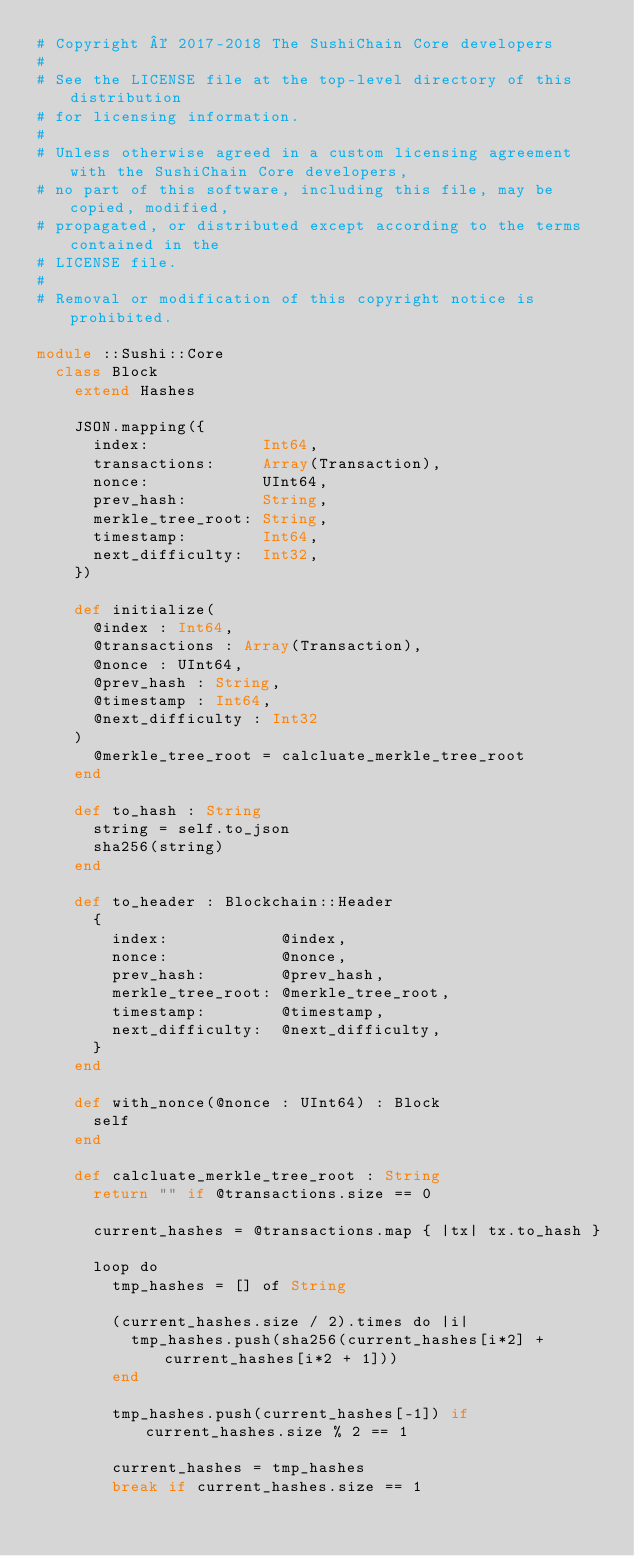<code> <loc_0><loc_0><loc_500><loc_500><_Crystal_># Copyright © 2017-2018 The SushiChain Core developers
#
# See the LICENSE file at the top-level directory of this distribution
# for licensing information.
#
# Unless otherwise agreed in a custom licensing agreement with the SushiChain Core developers,
# no part of this software, including this file, may be copied, modified,
# propagated, or distributed except according to the terms contained in the
# LICENSE file.
#
# Removal or modification of this copyright notice is prohibited.

module ::Sushi::Core
  class Block
    extend Hashes

    JSON.mapping({
      index:            Int64,
      transactions:     Array(Transaction),
      nonce:            UInt64,
      prev_hash:        String,
      merkle_tree_root: String,
      timestamp:        Int64,
      next_difficulty:  Int32,
    })

    def initialize(
      @index : Int64,
      @transactions : Array(Transaction),
      @nonce : UInt64,
      @prev_hash : String,
      @timestamp : Int64,
      @next_difficulty : Int32
    )
      @merkle_tree_root = calcluate_merkle_tree_root
    end

    def to_hash : String
      string = self.to_json
      sha256(string)
    end

    def to_header : Blockchain::Header
      {
        index:            @index,
        nonce:            @nonce,
        prev_hash:        @prev_hash,
        merkle_tree_root: @merkle_tree_root,
        timestamp:        @timestamp,
        next_difficulty:  @next_difficulty,
      }
    end

    def with_nonce(@nonce : UInt64) : Block
      self
    end

    def calcluate_merkle_tree_root : String
      return "" if @transactions.size == 0

      current_hashes = @transactions.map { |tx| tx.to_hash }

      loop do
        tmp_hashes = [] of String

        (current_hashes.size / 2).times do |i|
          tmp_hashes.push(sha256(current_hashes[i*2] + current_hashes[i*2 + 1]))
        end

        tmp_hashes.push(current_hashes[-1]) if current_hashes.size % 2 == 1

        current_hashes = tmp_hashes
        break if current_hashes.size == 1</code> 